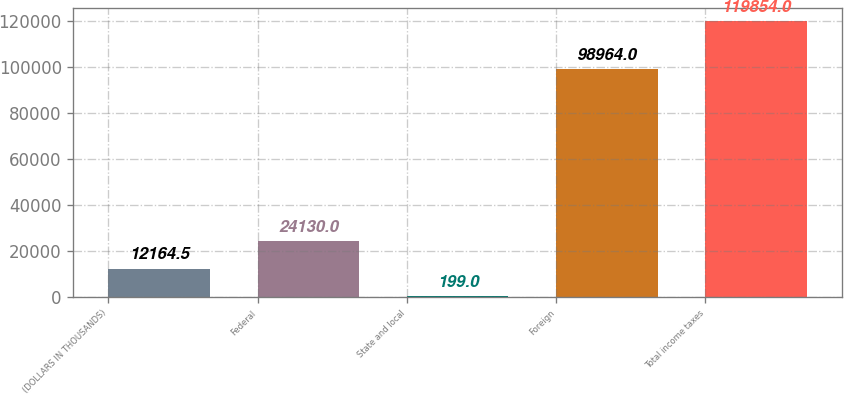Convert chart to OTSL. <chart><loc_0><loc_0><loc_500><loc_500><bar_chart><fcel>(DOLLARS IN THOUSANDS)<fcel>Federal<fcel>State and local<fcel>Foreign<fcel>Total income taxes<nl><fcel>12164.5<fcel>24130<fcel>199<fcel>98964<fcel>119854<nl></chart> 